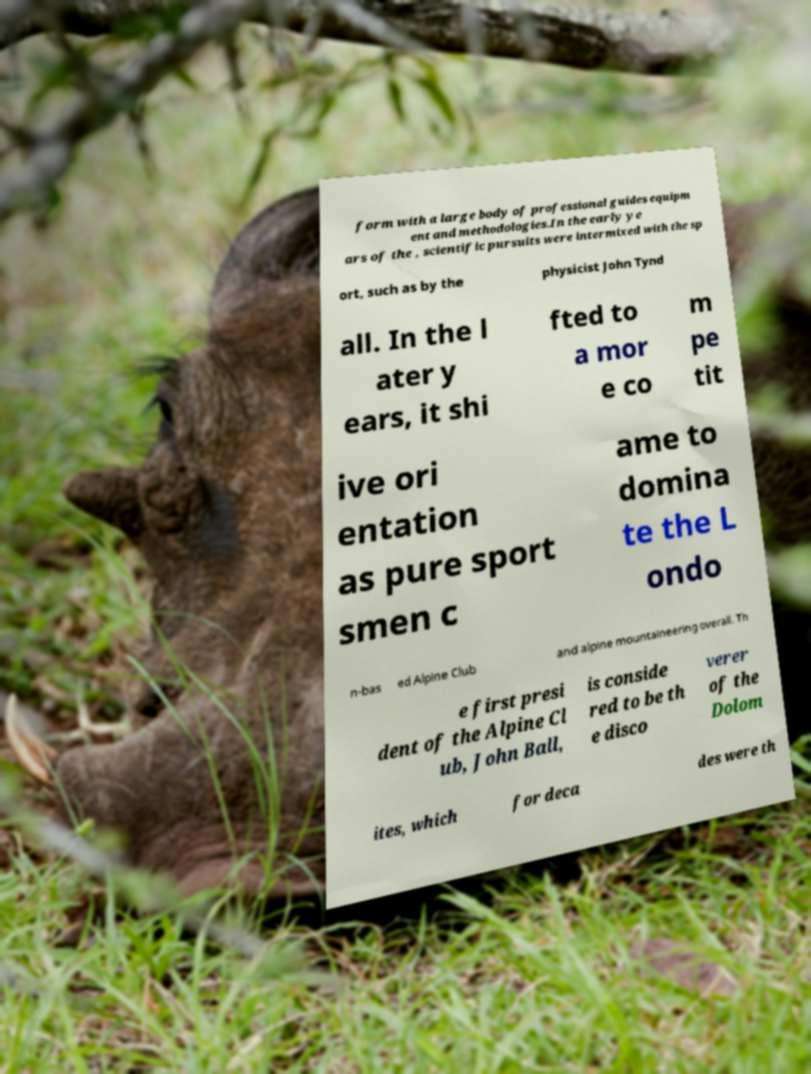Can you read and provide the text displayed in the image?This photo seems to have some interesting text. Can you extract and type it out for me? form with a large body of professional guides equipm ent and methodologies.In the early ye ars of the , scientific pursuits were intermixed with the sp ort, such as by the physicist John Tynd all. In the l ater y ears, it shi fted to a mor e co m pe tit ive ori entation as pure sport smen c ame to domina te the L ondo n-bas ed Alpine Club and alpine mountaineering overall. Th e first presi dent of the Alpine Cl ub, John Ball, is conside red to be th e disco verer of the Dolom ites, which for deca des were th 